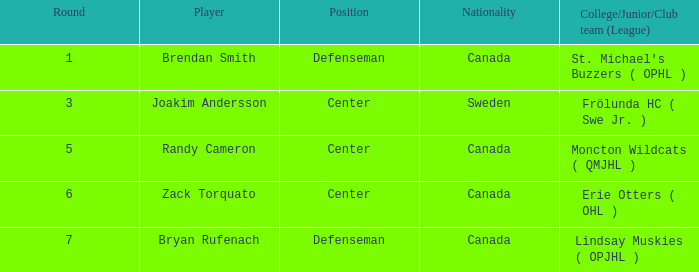Where is the birthplace of center joakim andersson? Sweden. 